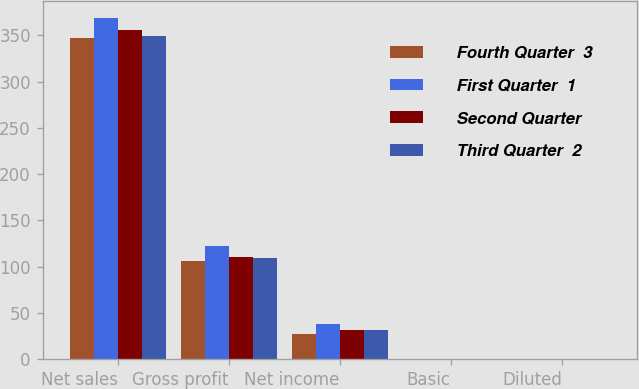Convert chart to OTSL. <chart><loc_0><loc_0><loc_500><loc_500><stacked_bar_chart><ecel><fcel>Net sales<fcel>Gross profit<fcel>Net income<fcel>Basic<fcel>Diluted<nl><fcel>Fourth Quarter  3<fcel>346.8<fcel>106.4<fcel>27.1<fcel>0.38<fcel>0.38<nl><fcel>First Quarter  1<fcel>368.9<fcel>121.8<fcel>37.6<fcel>0.53<fcel>0.52<nl><fcel>Second Quarter<fcel>355.9<fcel>109.9<fcel>31<fcel>0.44<fcel>0.43<nl><fcel>Third Quarter  2<fcel>349.8<fcel>109.7<fcel>31.4<fcel>0.44<fcel>0.43<nl></chart> 